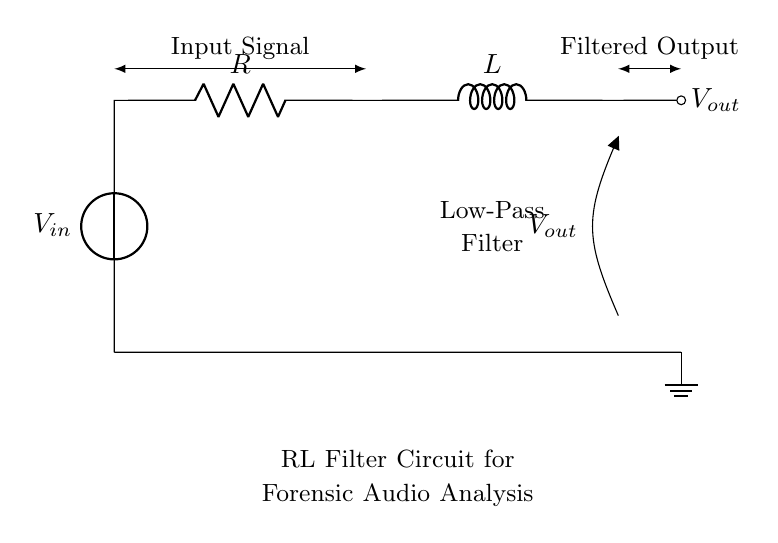What is the input voltage source labeled as? The input voltage source is labeled as V sub in, which denotes the voltage applied to the circuit.
Answer: V sub in What types of components are present in the circuit? The circuit contains a voltage source, a resistor, and an inductor, which are the fundamental components for creating an RL filter.
Answer: Voltage source, resistor, inductor What is the function of the circuit? The function of the circuit is to act as a low-pass filter, which allows lower frequencies to pass through while attenuating higher frequencies.
Answer: Low-pass filter What configuration does the resistor and inductor create? The resistor and inductor are connected in series; this means the current flows through the resistor and then the inductor sequentially, which defines the circuit’s filter characteristics.
Answer: Series configuration What is the expected behavior of the output voltage in response to a high-frequency input signal? The output voltage will decrease or be attenuated when a high-frequency input signal is applied because the filter is designed to block higher frequencies while allowing lower frequencies to pass.
Answer: Decrease What is the significance of the components' arrangement for forensic audio analysis? The arrangement of the resistor and inductor in an RL filter allows for the smoothing of audio signals, which is crucial in forensic audio analysis for enhancing audio clarity by reducing noise.
Answer: Enhances audio clarity What does the label on the output node indicate? The label on the output node indicates it is the point at which the filtered output voltage is measured from the circuit.
Answer: V sub out 